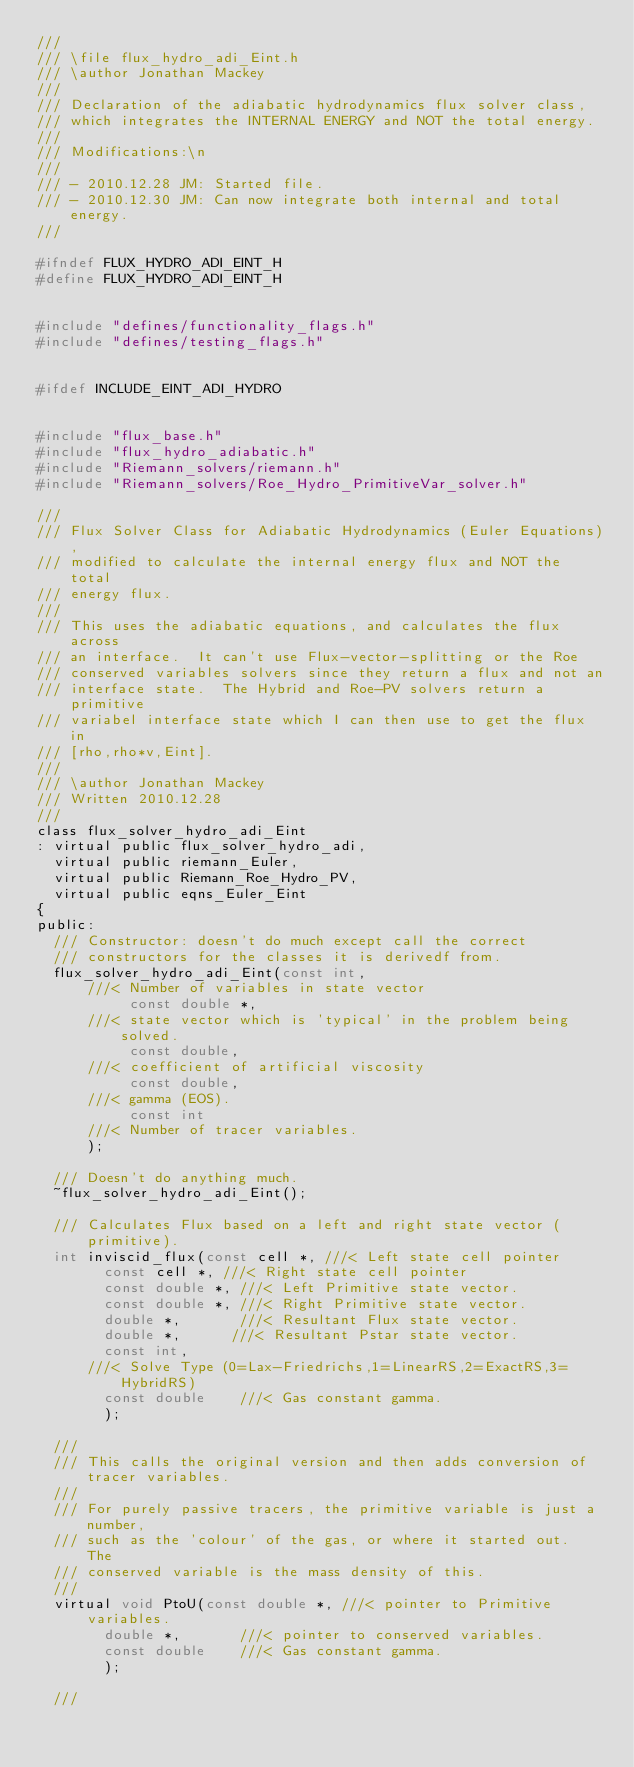<code> <loc_0><loc_0><loc_500><loc_500><_C_>///
/// \file flux_hydro_adi_Eint.h
/// \author Jonathan Mackey
///
/// Declaration of the adiabatic hydrodynamics flux solver class,
/// which integrates the INTERNAL ENERGY and NOT the total energy.
///
/// Modifications:\n
///
/// - 2010.12.28 JM: Started file.
/// - 2010.12.30 JM: Can now integrate both internal and total energy.
///

#ifndef FLUX_HYDRO_ADI_EINT_H
#define FLUX_HYDRO_ADI_EINT_H


#include "defines/functionality_flags.h"
#include "defines/testing_flags.h"


#ifdef INCLUDE_EINT_ADI_HYDRO


#include "flux_base.h"
#include "flux_hydro_adiabatic.h"
#include "Riemann_solvers/riemann.h"
#include "Riemann_solvers/Roe_Hydro_PrimitiveVar_solver.h"

///
/// Flux Solver Class for Adiabatic Hydrodynamics (Euler Equations), 
/// modified to calculate the internal energy flux and NOT the total
/// energy flux.
///
/// This uses the adiabatic equations, and calculates the flux across
/// an interface.  It can't use Flux-vector-splitting or the Roe
/// conserved variables solvers since they return a flux and not an 
/// interface state.  The Hybrid and Roe-PV solvers return a primitive
/// variabel interface state which I can then use to get the flux in
/// [rho,rho*v,Eint].
///
/// \author Jonathan Mackey
/// Written 2010.12.28
///
class flux_solver_hydro_adi_Eint
: virtual public flux_solver_hydro_adi,
  virtual public riemann_Euler,
  virtual public Riemann_Roe_Hydro_PV,
  virtual public eqns_Euler_Eint
{
public:
  /// Constructor: doesn't do much except call the correct
  /// constructors for the classes it is derivedf from.
  flux_solver_hydro_adi_Eint(const int,
      ///< Number of variables in state vector
			     const double *,
      ///< state vector which is 'typical' in the problem being solved. 
			     const double,
      ///< coefficient of artificial viscosity
			     const double,
      ///< gamma (EOS).
			     const int
      ///< Number of tracer variables.
			);

  /// Doesn't do anything much.
  ~flux_solver_hydro_adi_Eint();

  /// Calculates Flux based on a left and right state vector (primitive).
  int inviscid_flux(const cell *, ///< Left state cell pointer
		    const cell *, ///< Right state cell pointer
		    const double *, ///< Left Primitive state vector.
		    const double *, ///< Right Primitive state vector.
		    double *,       ///< Resultant Flux state vector.
		    double *,      ///< Resultant Pstar state vector.
		    const int,
      ///< Solve Type (0=Lax-Friedrichs,1=LinearRS,2=ExactRS,3=HybridRS)
		    const double    ///< Gas constant gamma.
		    );

  ///
  /// This calls the original version and then adds conversion of tracer variables.
  /// 
  /// For purely passive tracers, the primitive variable is just a number,
  /// such as the 'colour' of the gas, or where it started out.  The 
  /// conserved variable is the mass density of this.
  ///
  virtual void PtoU(const double *, ///< pointer to Primitive variables.
		    double *,       ///< pointer to conserved variables.
		    const double    ///< Gas constant gamma.
		    );

  ///</code> 